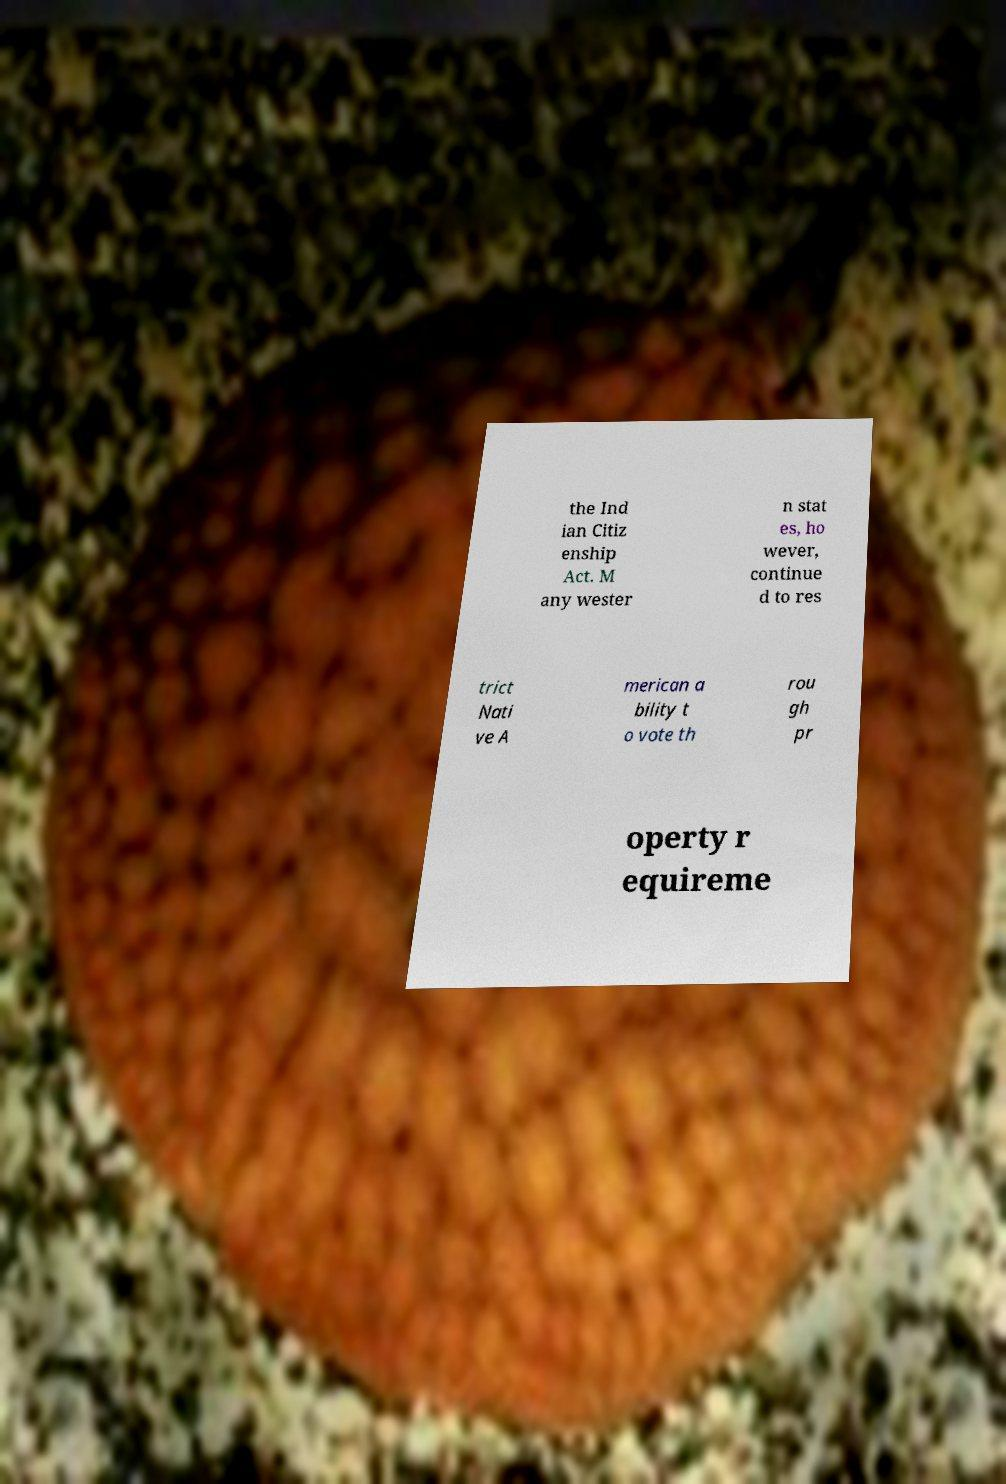For documentation purposes, I need the text within this image transcribed. Could you provide that? the Ind ian Citiz enship Act. M any wester n stat es, ho wever, continue d to res trict Nati ve A merican a bility t o vote th rou gh pr operty r equireme 